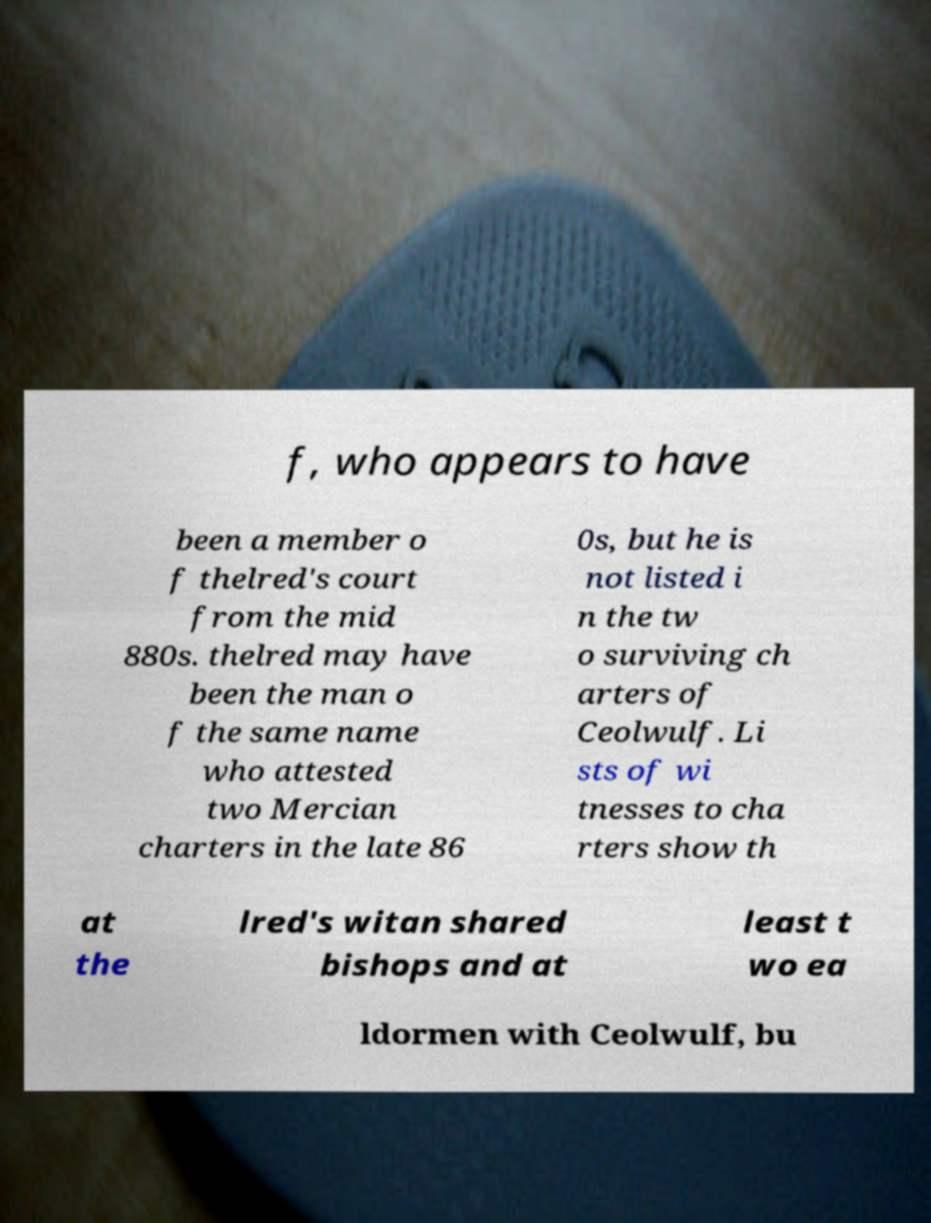What messages or text are displayed in this image? I need them in a readable, typed format. f, who appears to have been a member o f thelred's court from the mid 880s. thelred may have been the man o f the same name who attested two Mercian charters in the late 86 0s, but he is not listed i n the tw o surviving ch arters of Ceolwulf. Li sts of wi tnesses to cha rters show th at the lred's witan shared bishops and at least t wo ea ldormen with Ceolwulf, bu 